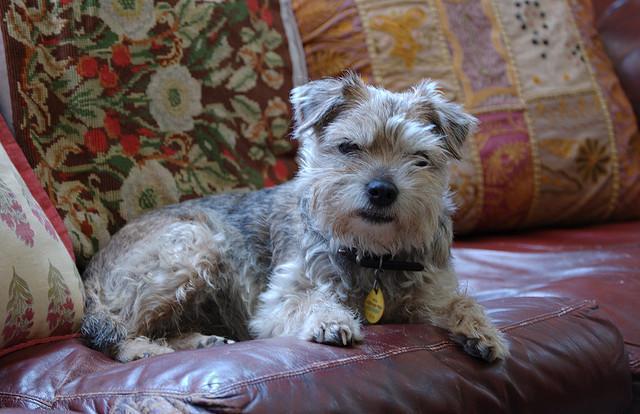How many couches are there?
Give a very brief answer. 1. 